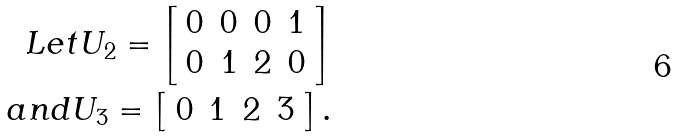<formula> <loc_0><loc_0><loc_500><loc_500>L e t U _ { 2 } = \left [ \begin{array} { c c c c } 0 & 0 & 0 & 1 \\ 0 & 1 & 2 & 0 \\ \end{array} \right ] \\ a n d U _ { 3 } = \left [ \begin{array} { c c c c } 0 & 1 & 2 & 3 \end{array} \right ] . \\</formula> 